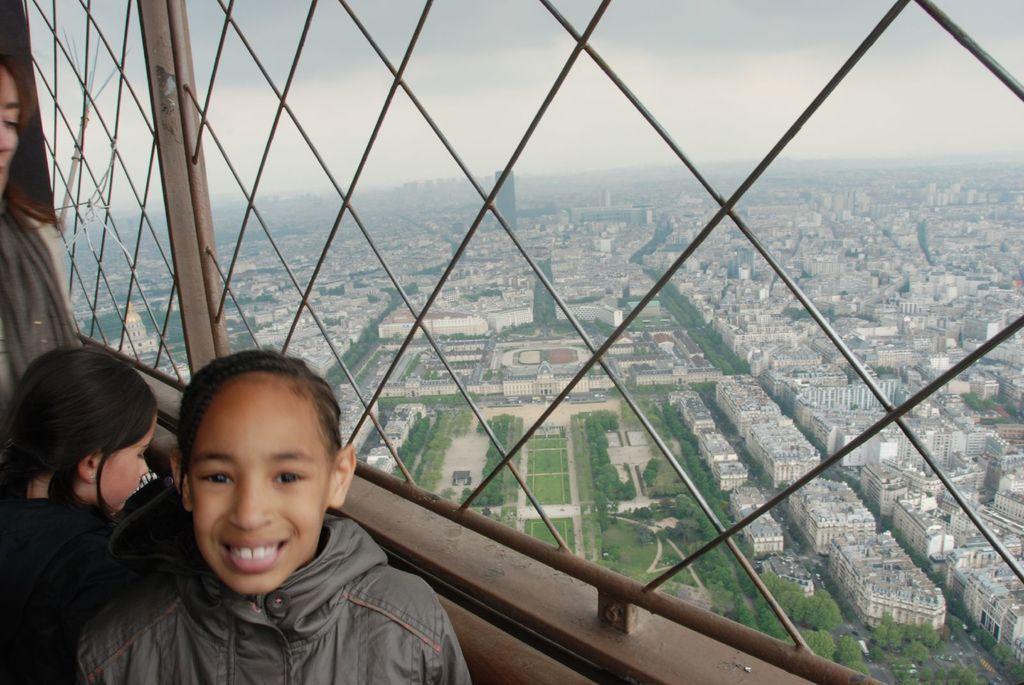Can you describe this image briefly? In this image I can see few people. I can see few buildings, trees, sky and few vehicles on the road. 